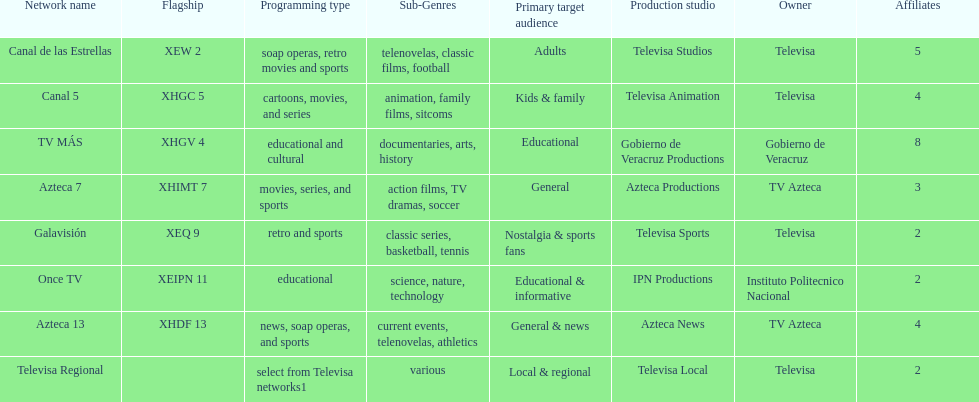What is the number of affiliates of canal de las estrellas. 5. 